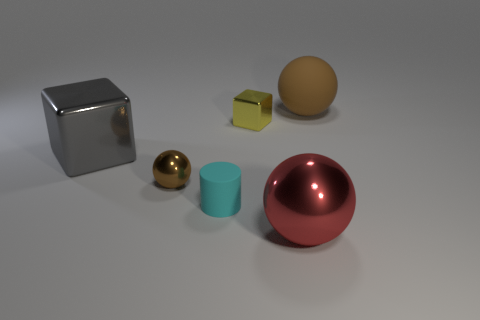The object that is to the right of the red thing that is on the right side of the metal block on the left side of the brown metallic ball is made of what material?
Make the answer very short. Rubber. How many objects are either yellow objects or big metal spheres?
Keep it short and to the point. 2. Is the color of the big sphere behind the tiny shiny ball the same as the metal ball that is left of the yellow object?
Your response must be concise. Yes. The gray metal object that is the same size as the brown matte thing is what shape?
Your response must be concise. Cube. How many objects are things that are in front of the small cyan object or metal objects that are in front of the small rubber cylinder?
Give a very brief answer. 1. Are there fewer small green matte things than brown matte things?
Provide a short and direct response. Yes. What is the material of the sphere that is the same size as the red metallic object?
Keep it short and to the point. Rubber. There is a thing on the right side of the large red thing; is its size the same as the matte thing in front of the big cube?
Make the answer very short. No. Is there a tiny green cylinder that has the same material as the tiny yellow object?
Your answer should be compact. No. What number of things are either brown balls to the left of the matte sphere or tiny cyan rubber objects?
Your answer should be very brief. 2. 